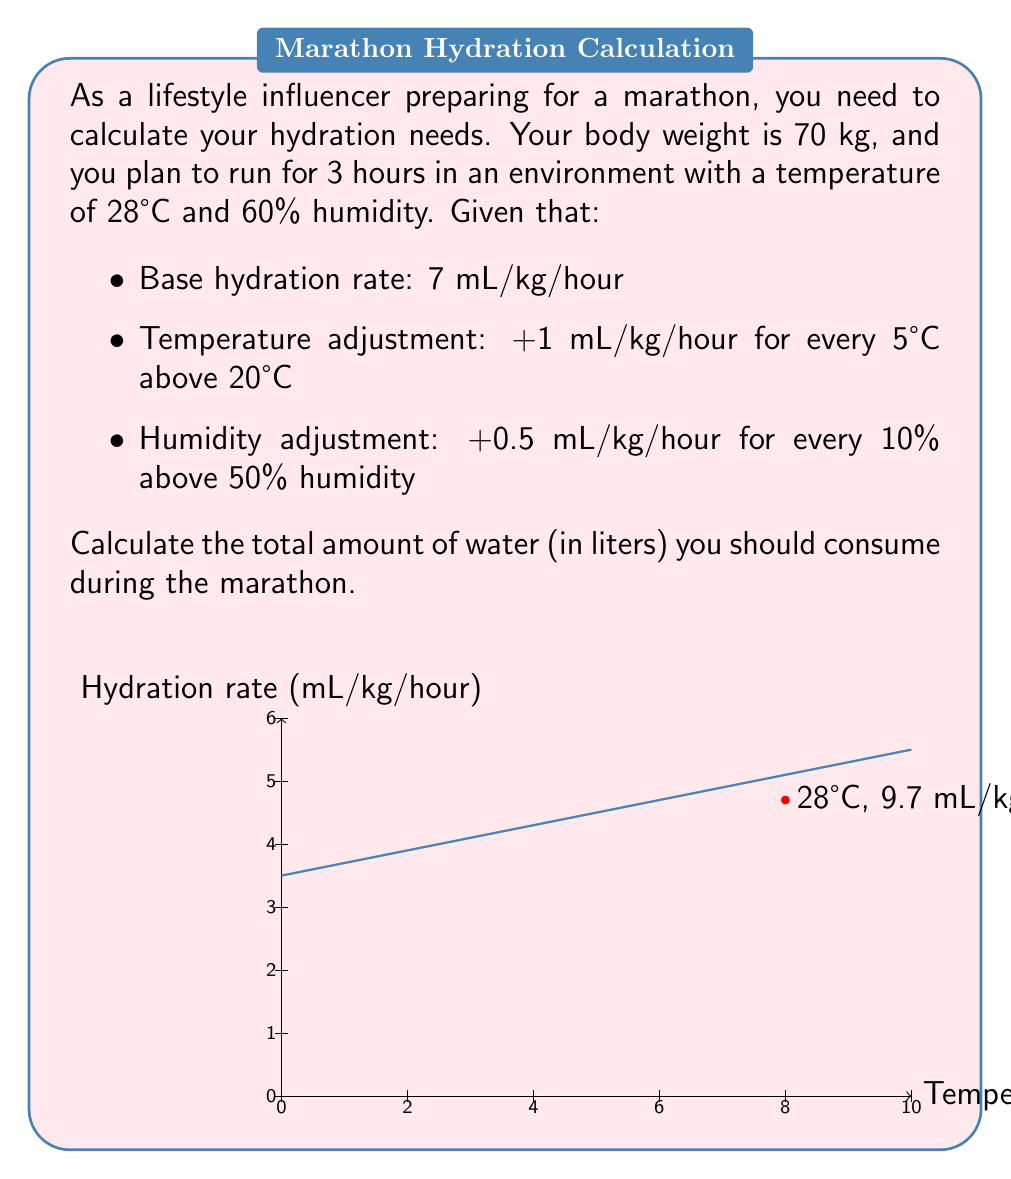Solve this math problem. Let's break this down step-by-step:

1) First, calculate the temperature adjustment:
   $$\text{Temp. adjustment} = \frac{28°C - 20°C}{5°C} = 1.6 \text{ mL/kg/hour}$$

2) Next, calculate the humidity adjustment:
   $$\text{Humidity adjustment} = \frac{60\% - 50\%}{10\%} \times 0.5 = 0.5 \text{ mL/kg/hour}$$

3) Now, calculate the total hydration rate:
   $$\text{Total rate} = 7 + 1.6 + 0.5 = 9.1 \text{ mL/kg/hour}$$

4) Calculate the hydration needs per hour:
   $$9.1 \text{ mL/kg/hour} \times 70 \text{ kg} = 637 \text{ mL/hour}$$

5) For the entire 3-hour marathon:
   $$637 \text{ mL/hour} \times 3 \text{ hours} = 1911 \text{ mL}$$

6) Convert to liters:
   $$1911 \text{ mL} = 1.911 \text{ L}$$

Therefore, you should consume approximately 1.911 liters of water during the marathon.
Answer: 1.911 L 